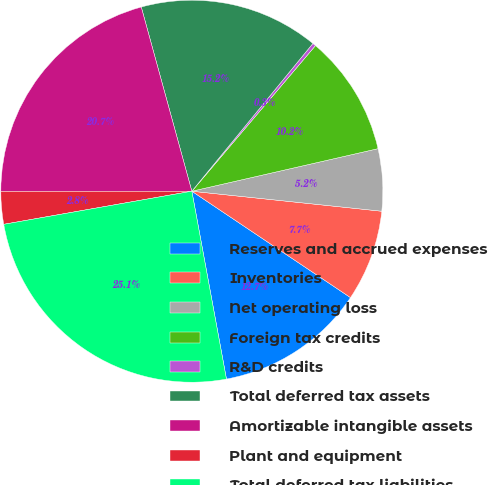Convert chart to OTSL. <chart><loc_0><loc_0><loc_500><loc_500><pie_chart><fcel>Reserves and accrued expenses<fcel>Inventories<fcel>Net operating loss<fcel>Foreign tax credits<fcel>R&D credits<fcel>Total deferred tax assets<fcel>Amortizable intangible assets<fcel>Plant and equipment<fcel>Total deferred tax liabilities<nl><fcel>12.7%<fcel>7.73%<fcel>5.25%<fcel>10.22%<fcel>0.28%<fcel>15.19%<fcel>20.75%<fcel>2.76%<fcel>25.13%<nl></chart> 